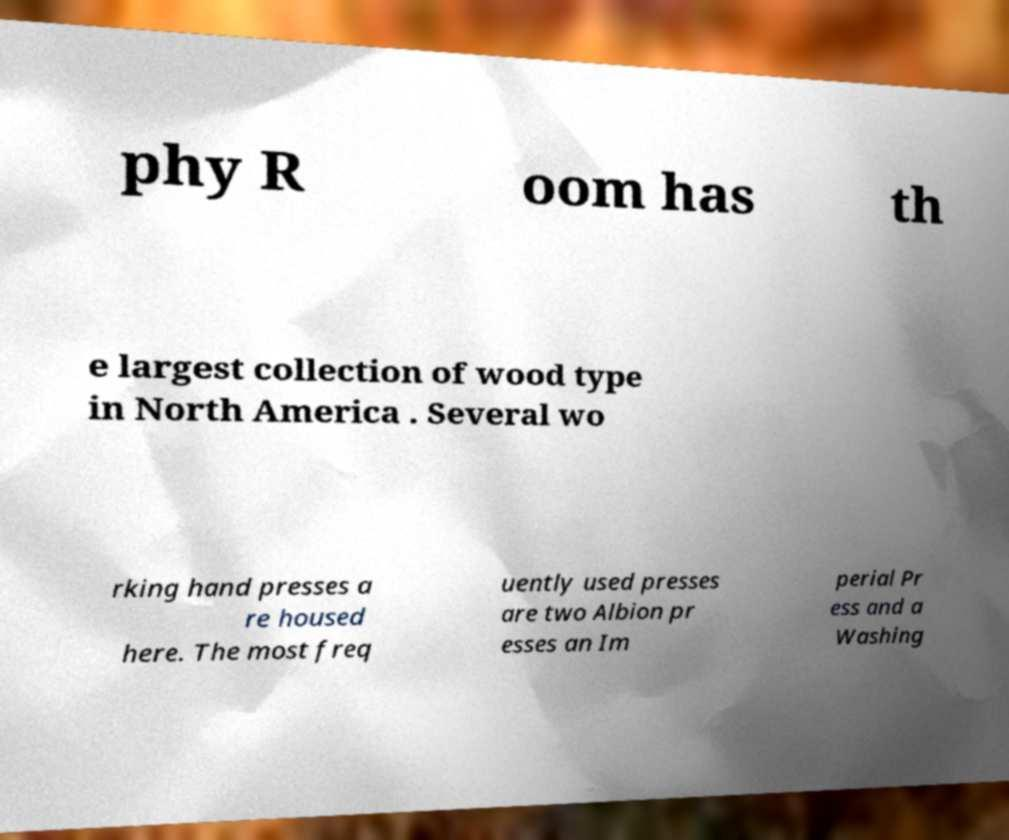Can you read and provide the text displayed in the image?This photo seems to have some interesting text. Can you extract and type it out for me? phy R oom has th e largest collection of wood type in North America . Several wo rking hand presses a re housed here. The most freq uently used presses are two Albion pr esses an Im perial Pr ess and a Washing 